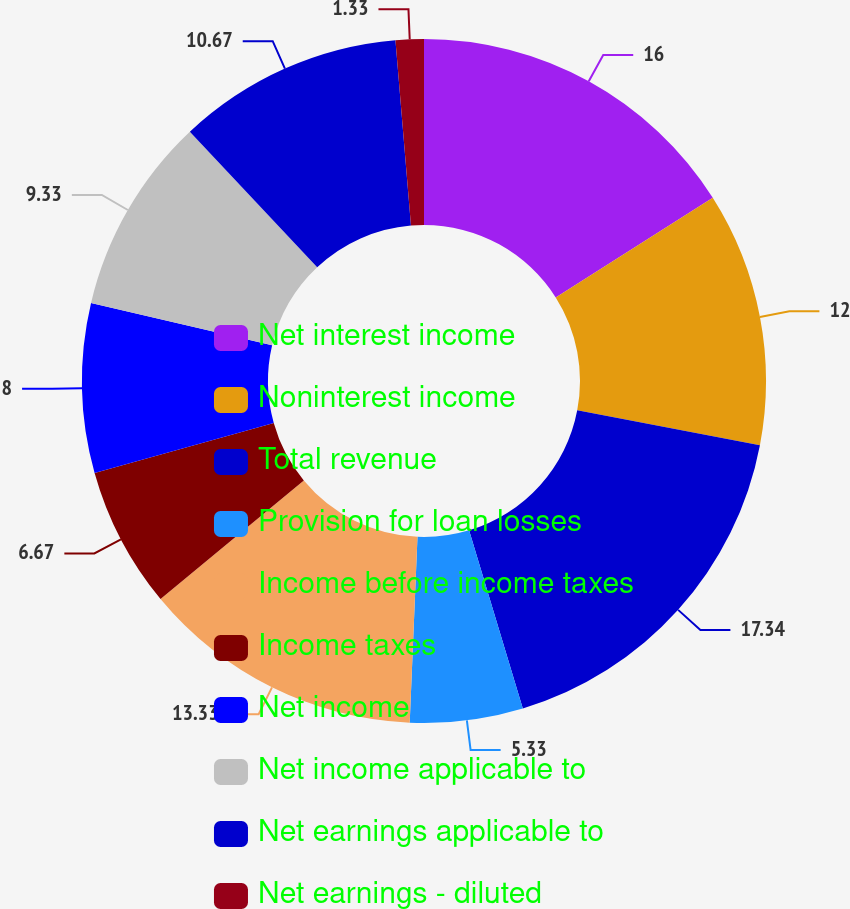<chart> <loc_0><loc_0><loc_500><loc_500><pie_chart><fcel>Net interest income<fcel>Noninterest income<fcel>Total revenue<fcel>Provision for loan losses<fcel>Income before income taxes<fcel>Income taxes<fcel>Net income<fcel>Net income applicable to<fcel>Net earnings applicable to<fcel>Net earnings - diluted<nl><fcel>16.0%<fcel>12.0%<fcel>17.33%<fcel>5.33%<fcel>13.33%<fcel>6.67%<fcel>8.0%<fcel>9.33%<fcel>10.67%<fcel>1.33%<nl></chart> 